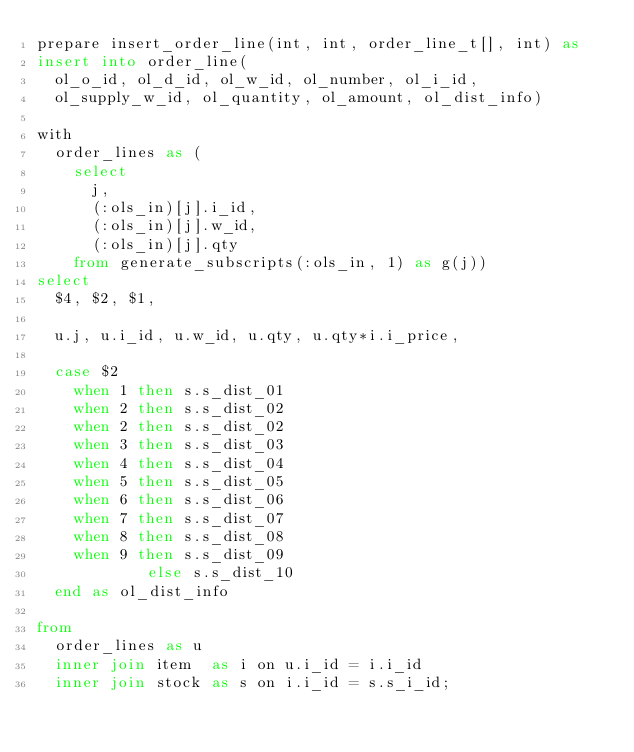<code> <loc_0><loc_0><loc_500><loc_500><_SQL_>prepare insert_order_line(int, int, order_line_t[], int) as
insert into order_line(
  ol_o_id, ol_d_id, ol_w_id, ol_number, ol_i_id, 
  ol_supply_w_id, ol_quantity, ol_amount, ol_dist_info)

with
  order_lines as (
    select
      j,
      (:ols_in)[j].i_id,
      (:ols_in)[j].w_id,
      (:ols_in)[j].qty
    from generate_subscripts(:ols_in, 1) as g(j))
select
  $4, $2, $1,

  u.j, u.i_id, u.w_id, u.qty, u.qty*i.i_price,

  case $2
    when 1 then s.s_dist_01
    when 2 then s.s_dist_02
    when 2 then s.s_dist_02
    when 3 then s.s_dist_03
    when 4 then s.s_dist_04
    when 5 then s.s_dist_05
    when 6 then s.s_dist_06
    when 7 then s.s_dist_07
    when 8 then s.s_dist_08
    when 9 then s.s_dist_09
            else s.s_dist_10
  end as ol_dist_info

from
  order_lines as u
  inner join item  as i on u.i_id = i.i_id
  inner join stock as s on i.i_id = s.s_i_id;
</code> 